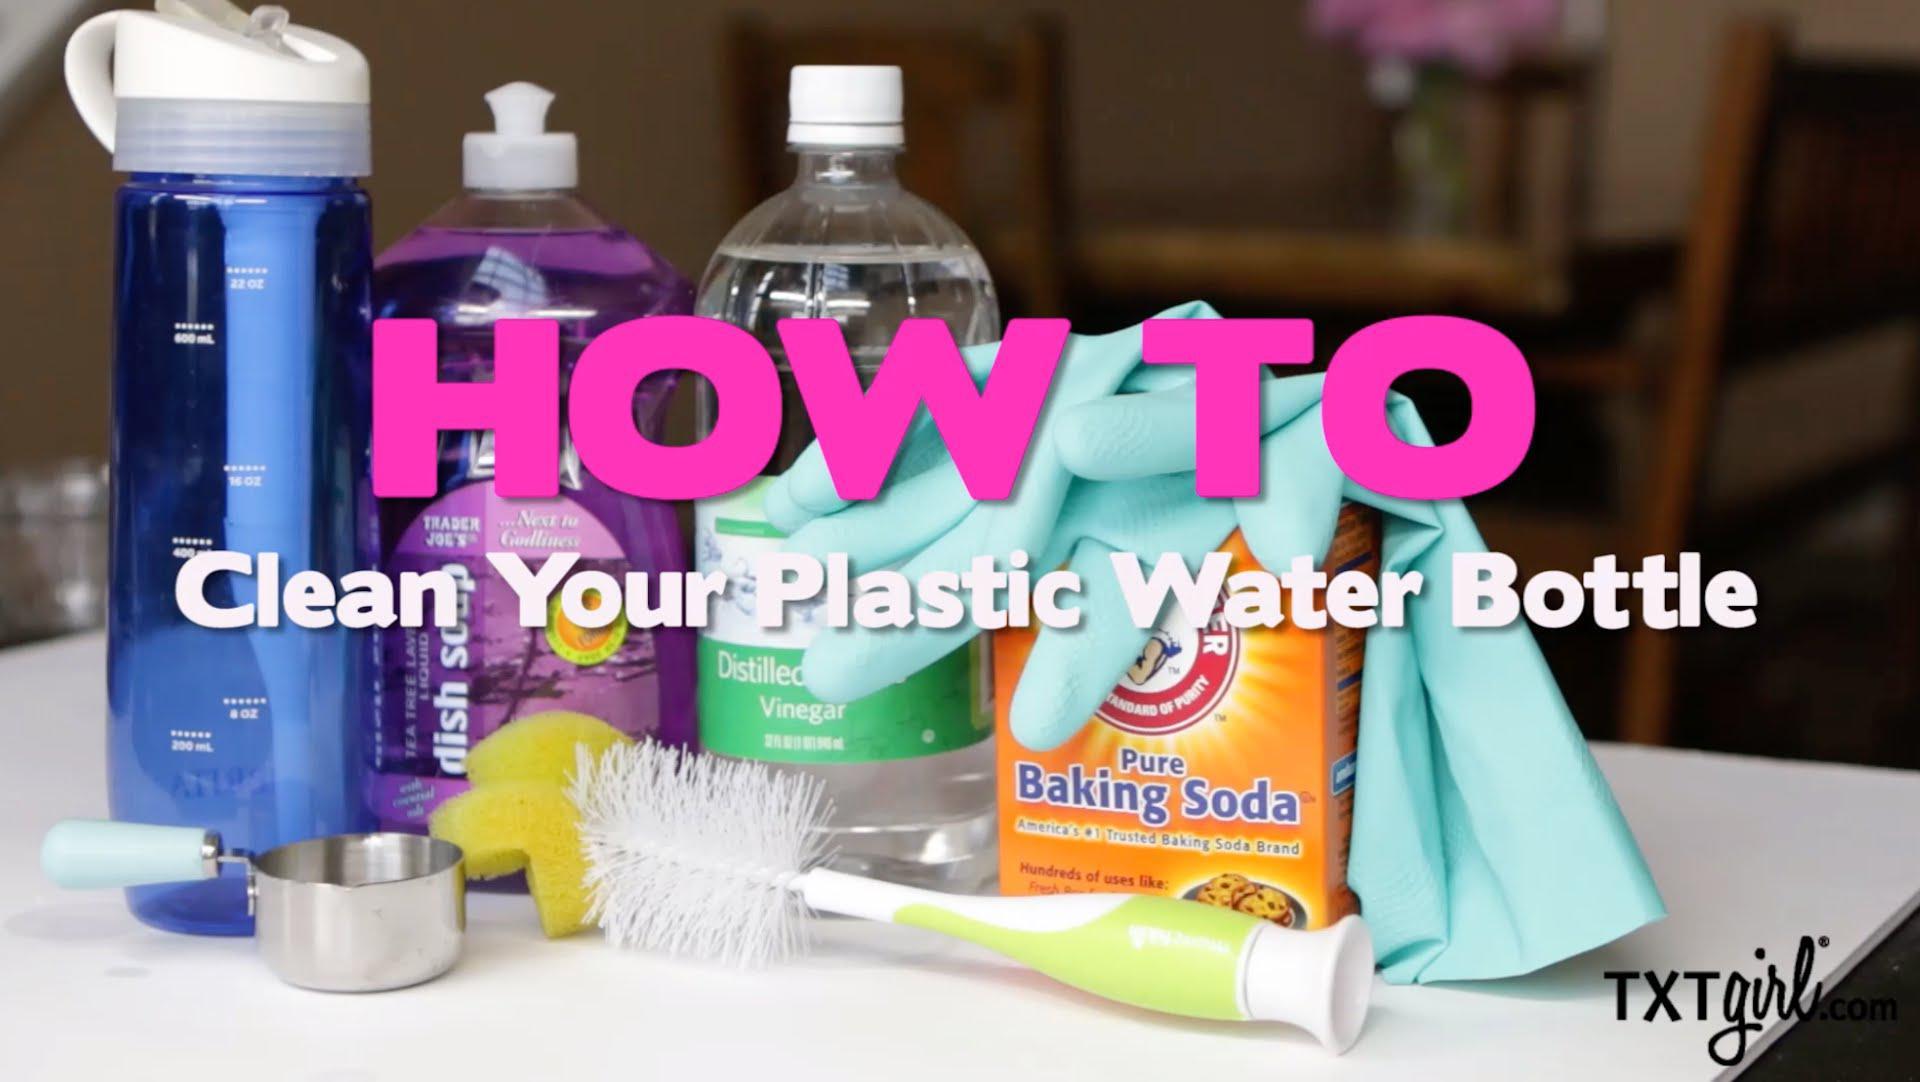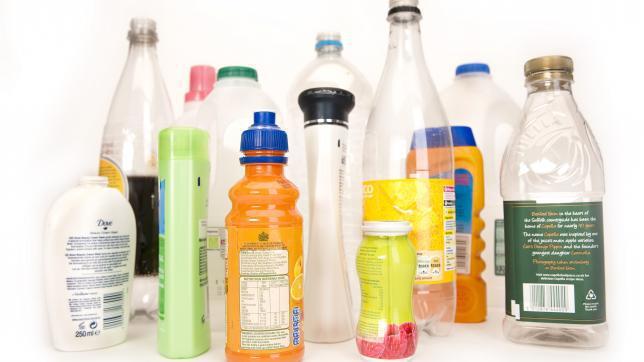The first image is the image on the left, the second image is the image on the right. Assess this claim about the two images: "In at least one image there are at least two plastic bottles with no lids.". Correct or not? Answer yes or no. No. 